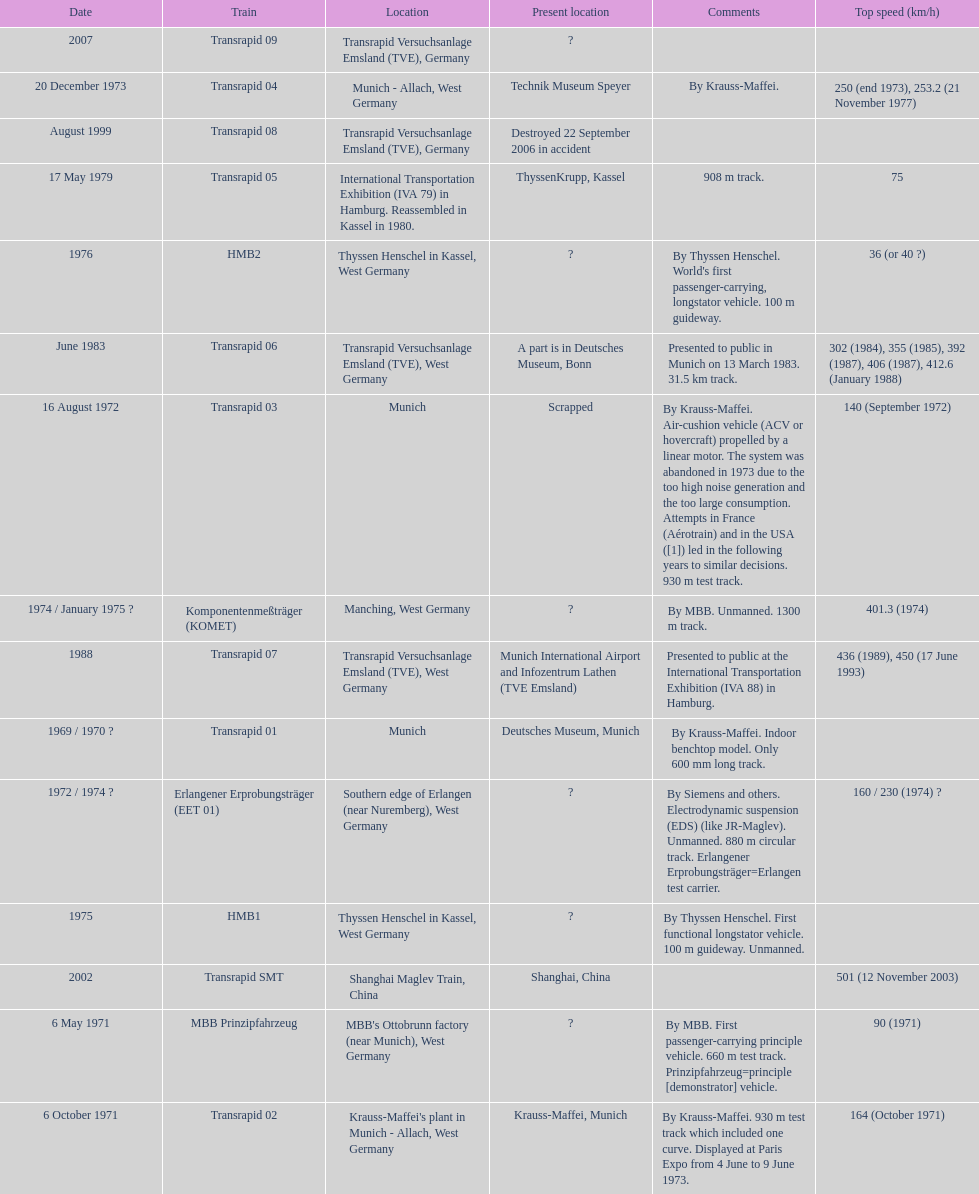How many trains listed have the same speed as the hmb2? 0. I'm looking to parse the entire table for insights. Could you assist me with that? {'header': ['Date', 'Train', 'Location', 'Present location', 'Comments', 'Top speed (km/h)'], 'rows': [['2007', 'Transrapid 09', 'Transrapid Versuchsanlage Emsland (TVE), Germany', '?', '', ''], ['20 December 1973', 'Transrapid 04', 'Munich - Allach, West Germany', 'Technik Museum Speyer', 'By Krauss-Maffei.', '250 (end 1973), 253.2 (21 November 1977)'], ['August 1999', 'Transrapid 08', 'Transrapid Versuchsanlage Emsland (TVE), Germany', 'Destroyed 22 September 2006 in accident', '', ''], ['17 May 1979', 'Transrapid 05', 'International Transportation Exhibition (IVA 79) in Hamburg. Reassembled in Kassel in 1980.', 'ThyssenKrupp, Kassel', '908 m track.', '75'], ['1976', 'HMB2', 'Thyssen Henschel in Kassel, West Germany', '?', "By Thyssen Henschel. World's first passenger-carrying, longstator vehicle. 100 m guideway.", '36 (or 40\xa0?)'], ['June 1983', 'Transrapid 06', 'Transrapid Versuchsanlage Emsland (TVE), West Germany', 'A part is in Deutsches Museum, Bonn', 'Presented to public in Munich on 13 March 1983. 31.5\xa0km track.', '302 (1984), 355 (1985), 392 (1987), 406 (1987), 412.6 (January 1988)'], ['16 August 1972', 'Transrapid 03', 'Munich', 'Scrapped', 'By Krauss-Maffei. Air-cushion vehicle (ACV or hovercraft) propelled by a linear motor. The system was abandoned in 1973 due to the too high noise generation and the too large consumption. Attempts in France (Aérotrain) and in the USA ([1]) led in the following years to similar decisions. 930 m test track.', '140 (September 1972)'], ['1974 / January 1975\xa0?', 'Komponentenmeßträger (KOMET)', 'Manching, West Germany', '?', 'By MBB. Unmanned. 1300 m track.', '401.3 (1974)'], ['1988', 'Transrapid 07', 'Transrapid Versuchsanlage Emsland (TVE), West Germany', 'Munich International Airport and Infozentrum Lathen (TVE Emsland)', 'Presented to public at the International Transportation Exhibition (IVA 88) in Hamburg.', '436 (1989), 450 (17 June 1993)'], ['1969 / 1970\xa0?', 'Transrapid 01', 'Munich', 'Deutsches Museum, Munich', 'By Krauss-Maffei. Indoor benchtop model. Only 600\xa0mm long track.', ''], ['1972 / 1974\xa0?', 'Erlangener Erprobungsträger (EET 01)', 'Southern edge of Erlangen (near Nuremberg), West Germany', '?', 'By Siemens and others. Electrodynamic suspension (EDS) (like JR-Maglev). Unmanned. 880 m circular track. Erlangener Erprobungsträger=Erlangen test carrier.', '160 / 230 (1974)\xa0?'], ['1975', 'HMB1', 'Thyssen Henschel in Kassel, West Germany', '?', 'By Thyssen Henschel. First functional longstator vehicle. 100 m guideway. Unmanned.', ''], ['2002', 'Transrapid SMT', 'Shanghai Maglev Train, China', 'Shanghai, China', '', '501 (12 November 2003)'], ['6 May 1971', 'MBB Prinzipfahrzeug', "MBB's Ottobrunn factory (near Munich), West Germany", '?', 'By MBB. First passenger-carrying principle vehicle. 660 m test track. Prinzipfahrzeug=principle [demonstrator] vehicle.', '90 (1971)'], ['6 October 1971', 'Transrapid 02', "Krauss-Maffei's plant in Munich - Allach, West Germany", 'Krauss-Maffei, Munich', 'By Krauss-Maffei. 930 m test track which included one curve. Displayed at Paris Expo from 4 June to 9 June 1973.', '164 (October 1971)']]} 